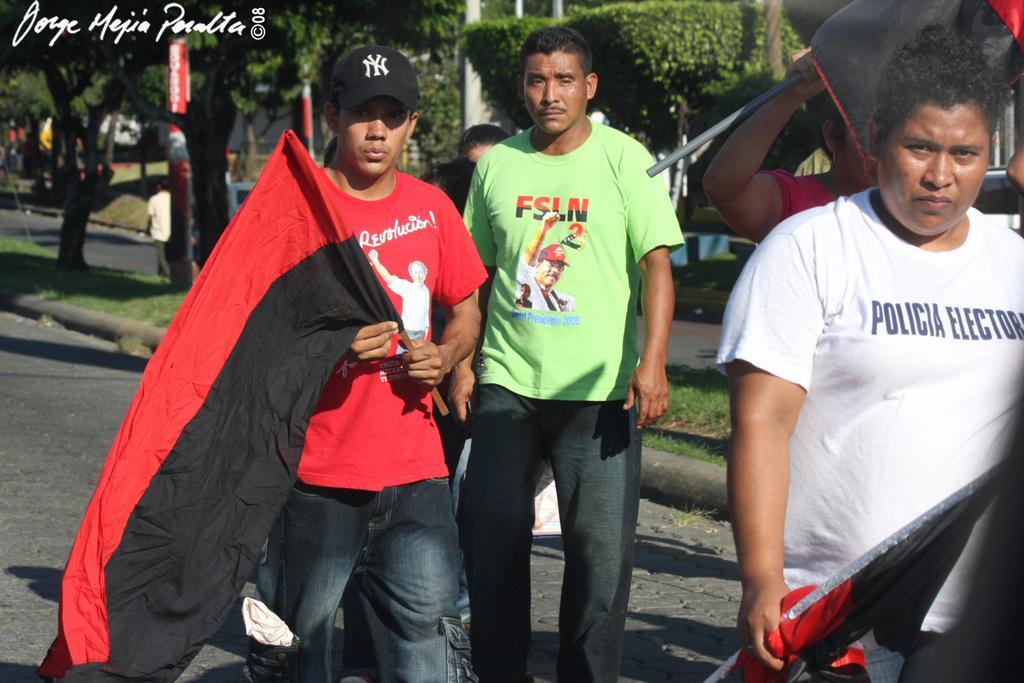Describe this image in one or two sentences. This image is taken outdoors. At the bottom of the image there is a road. In the middle of the image a few men are walking on the road and they are holding a few flags in their hands. In the background there are a few trees and a few people are walking on the road and there is a building. 